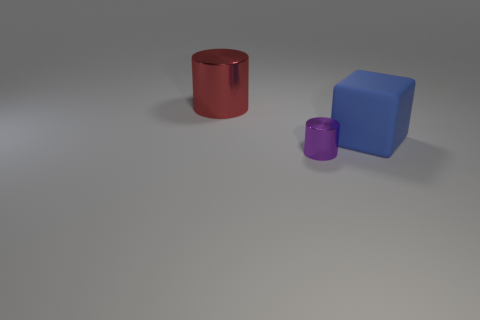Add 1 red metal cylinders. How many objects exist? 4 Subtract all cubes. How many objects are left? 2 Subtract 0 green cubes. How many objects are left? 3 Subtract all tiny metallic things. Subtract all big blue cubes. How many objects are left? 1 Add 3 small cylinders. How many small cylinders are left? 4 Add 3 red objects. How many red objects exist? 4 